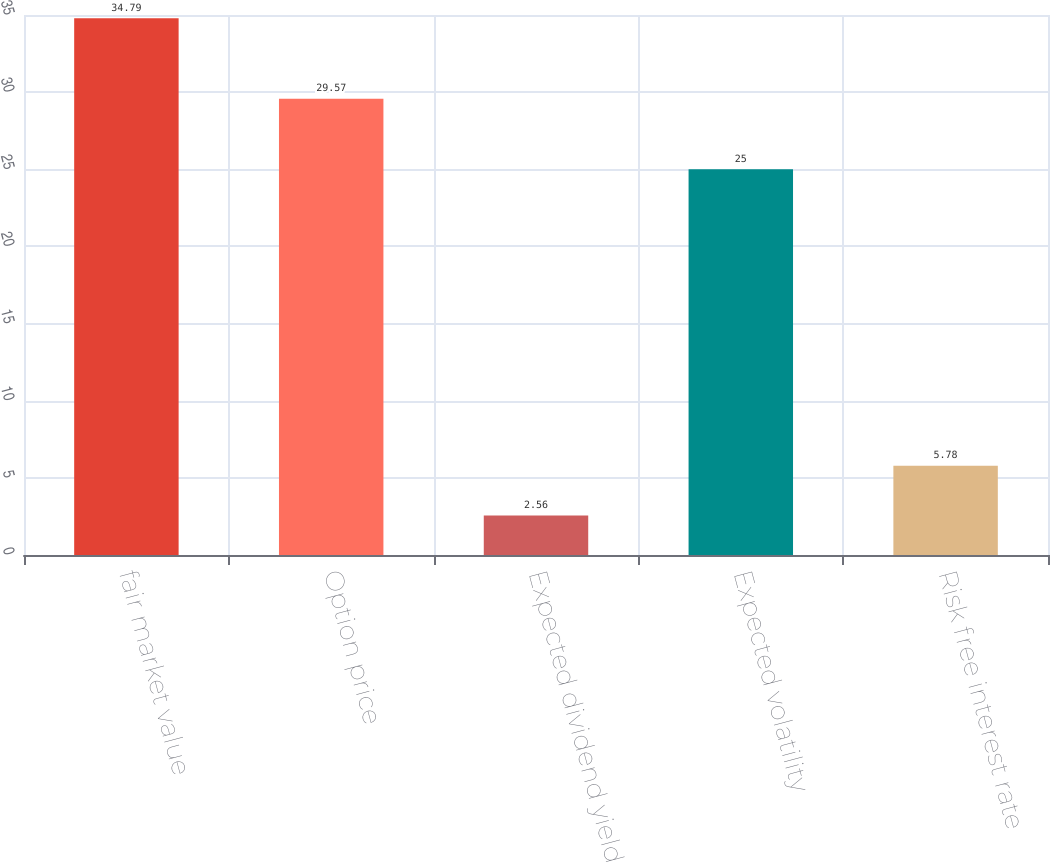<chart> <loc_0><loc_0><loc_500><loc_500><bar_chart><fcel>fair market value<fcel>Option price<fcel>Expected dividend yield<fcel>Expected volatility<fcel>Risk free interest rate<nl><fcel>34.79<fcel>29.57<fcel>2.56<fcel>25<fcel>5.78<nl></chart> 